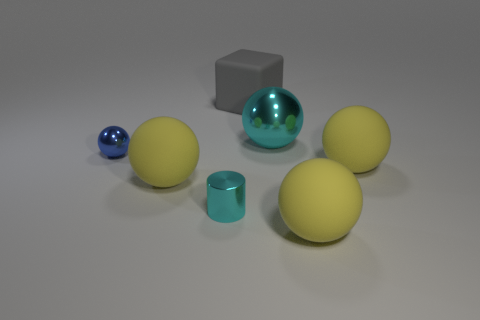Can you describe the arrangement of the objects? Certainly. The objects are arranged on a flat surface with the cyan sphere centrally positioned. The other spheres are scattered around it, with the blue one to its left and the yellow spheres to the right and in front. The gray cube stands behind the cyan sphere, providing contrast in shape and color. 